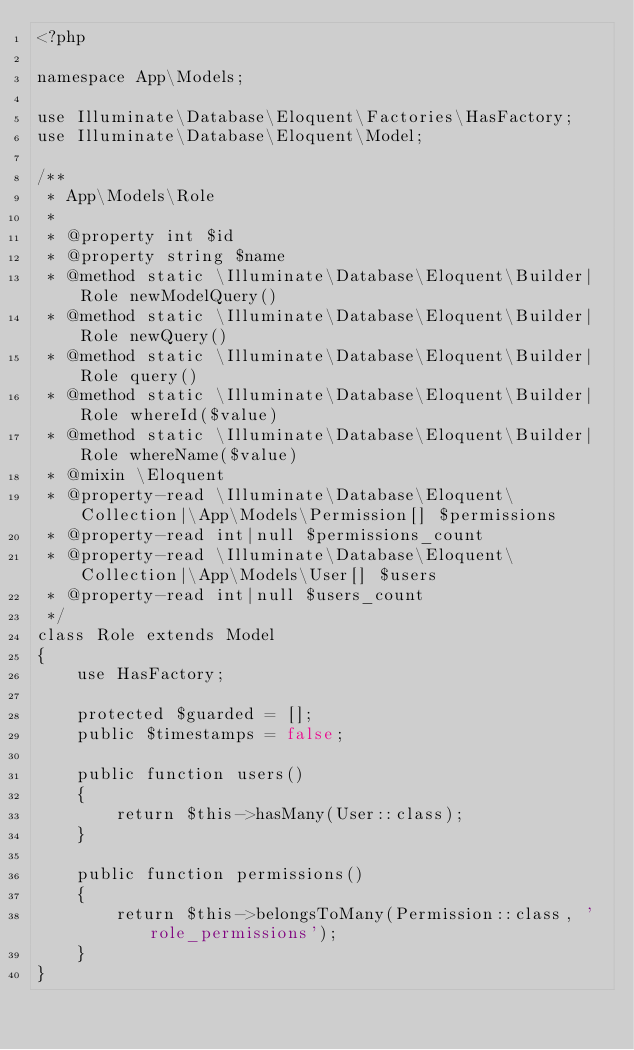Convert code to text. <code><loc_0><loc_0><loc_500><loc_500><_PHP_><?php

namespace App\Models;

use Illuminate\Database\Eloquent\Factories\HasFactory;
use Illuminate\Database\Eloquent\Model;

/**
 * App\Models\Role
 *
 * @property int $id
 * @property string $name
 * @method static \Illuminate\Database\Eloquent\Builder|Role newModelQuery()
 * @method static \Illuminate\Database\Eloquent\Builder|Role newQuery()
 * @method static \Illuminate\Database\Eloquent\Builder|Role query()
 * @method static \Illuminate\Database\Eloquent\Builder|Role whereId($value)
 * @method static \Illuminate\Database\Eloquent\Builder|Role whereName($value)
 * @mixin \Eloquent
 * @property-read \Illuminate\Database\Eloquent\Collection|\App\Models\Permission[] $permissions
 * @property-read int|null $permissions_count
 * @property-read \Illuminate\Database\Eloquent\Collection|\App\Models\User[] $users
 * @property-read int|null $users_count
 */
class Role extends Model
{
    use HasFactory;

    protected $guarded = [];
    public $timestamps = false;

    public function users()
    {
        return $this->hasMany(User::class);
    }

    public function permissions()
    {
        return $this->belongsToMany(Permission::class, 'role_permissions');
    }
}
</code> 